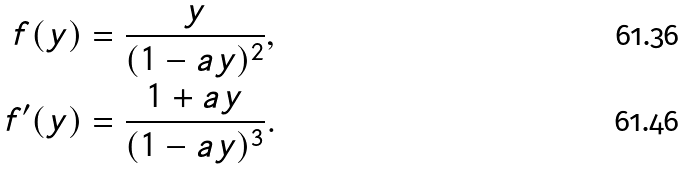<formula> <loc_0><loc_0><loc_500><loc_500>f ( y ) & = \frac { y } { ( 1 - a y ) ^ { 2 } } , \\ f ^ { \prime } ( y ) & = \frac { 1 + a y } { ( 1 - a y ) ^ { 3 } } .</formula> 